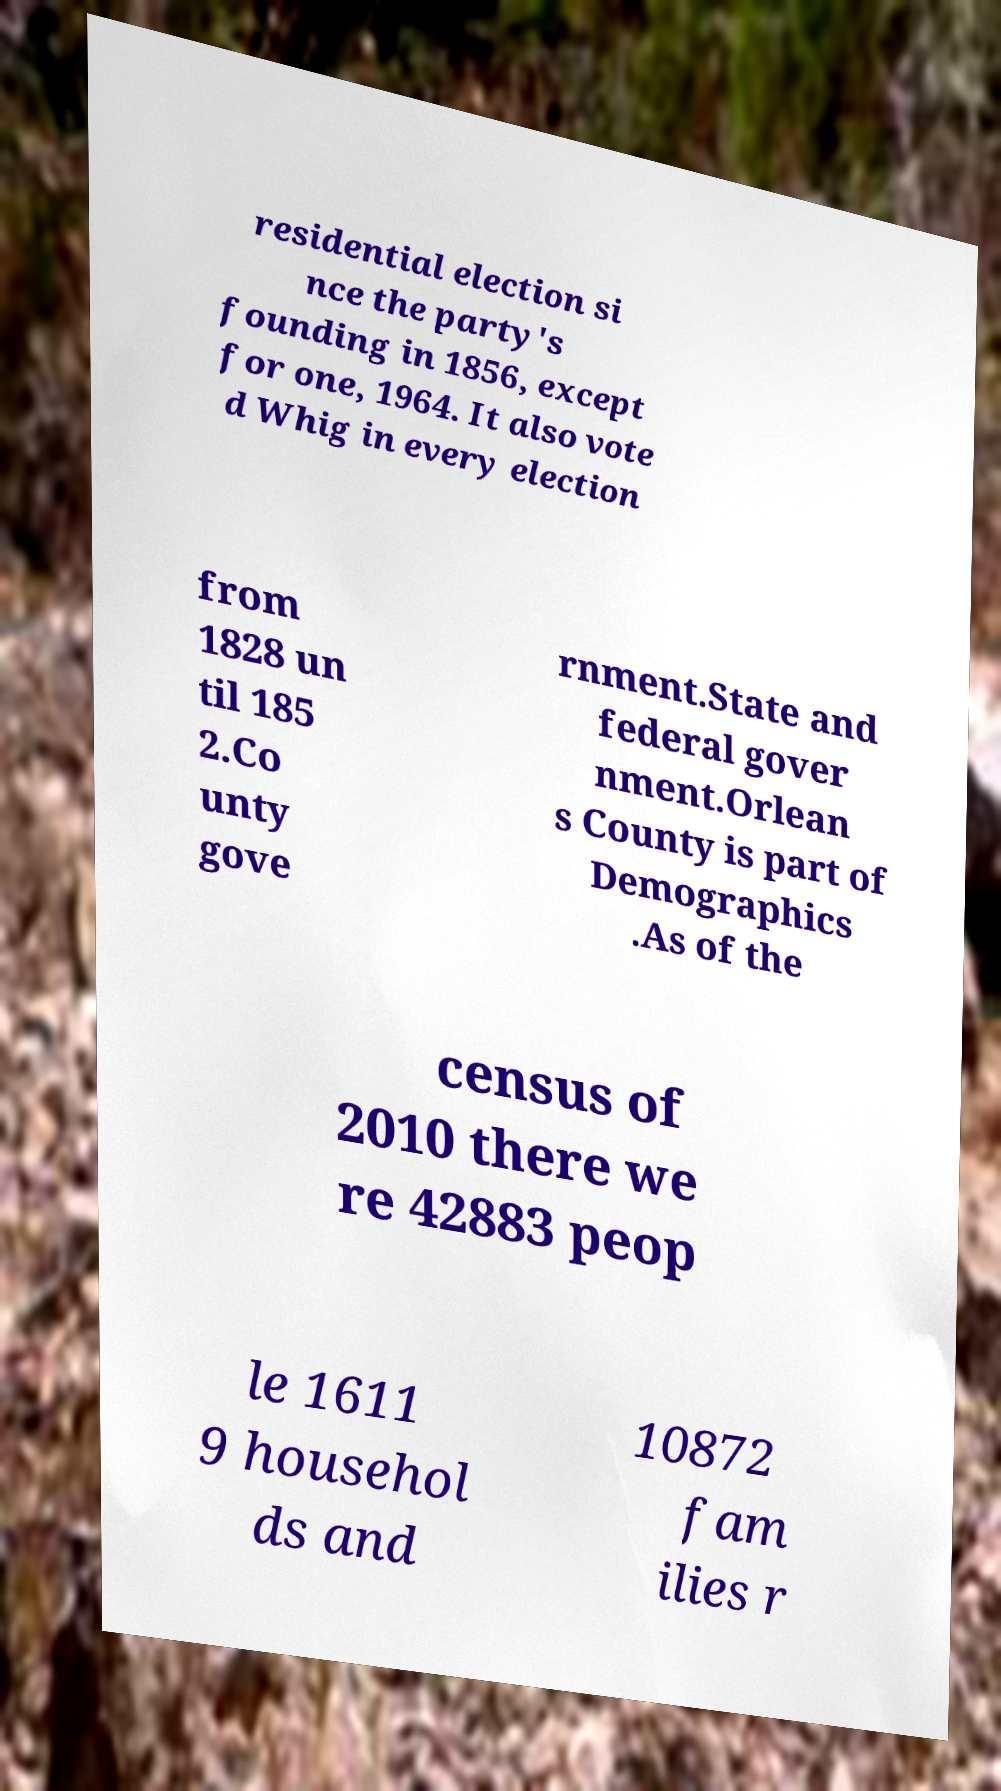I need the written content from this picture converted into text. Can you do that? residential election si nce the party's founding in 1856, except for one, 1964. It also vote d Whig in every election from 1828 un til 185 2.Co unty gove rnment.State and federal gover nment.Orlean s County is part of Demographics .As of the census of 2010 there we re 42883 peop le 1611 9 househol ds and 10872 fam ilies r 